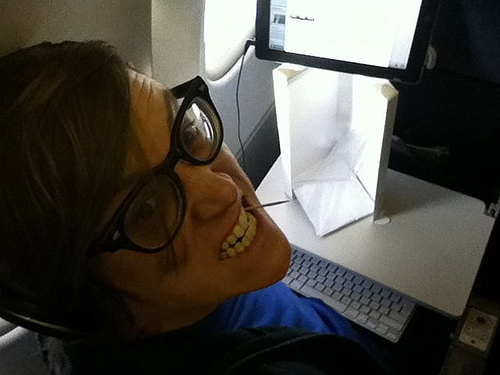Do you think the shirt is black? No, the shirt is not black. 